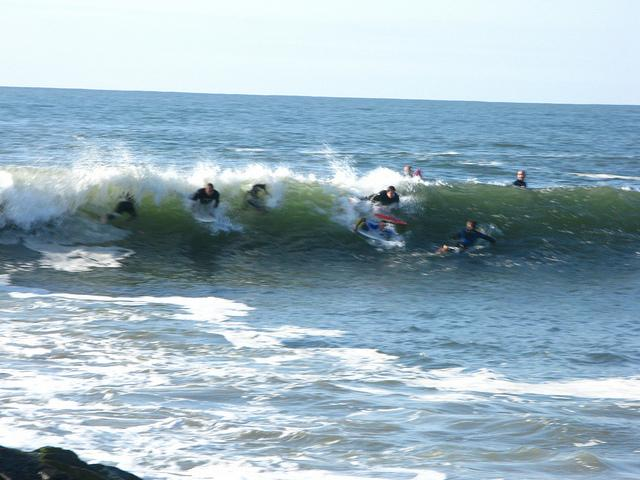What are the surfers in a push up position attempting to do? Please explain your reasoning. stand. The surfers want to get up. 